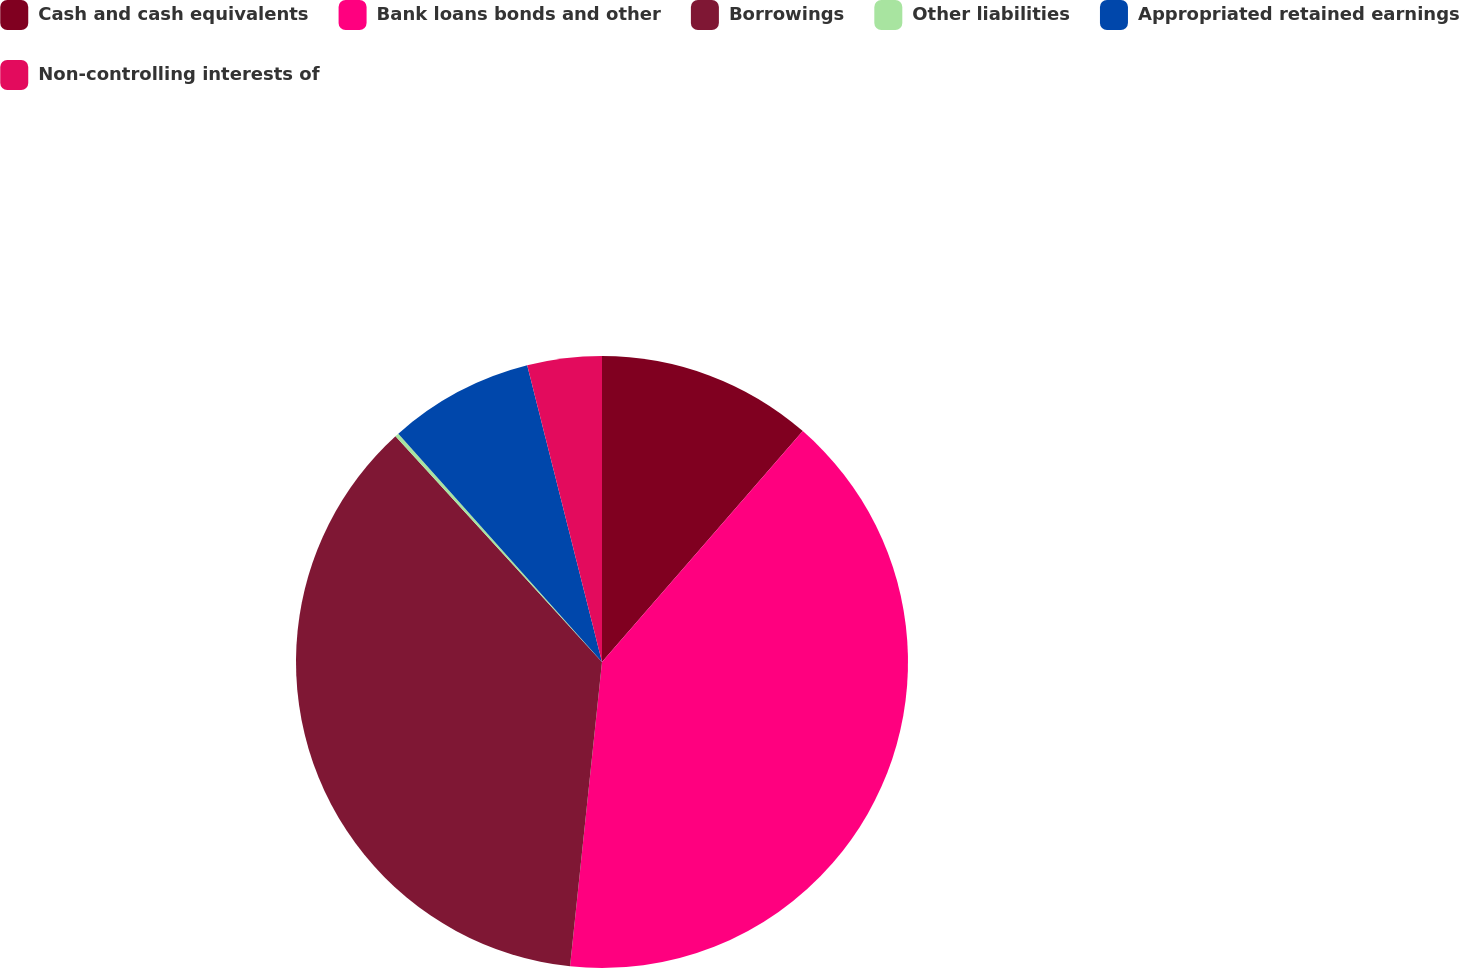<chart> <loc_0><loc_0><loc_500><loc_500><pie_chart><fcel>Cash and cash equivalents<fcel>Bank loans bonds and other<fcel>Borrowings<fcel>Other liabilities<fcel>Appropriated retained earnings<fcel>Non-controlling interests of<nl><fcel>11.39%<fcel>40.27%<fcel>36.54%<fcel>0.2%<fcel>7.66%<fcel>3.93%<nl></chart> 